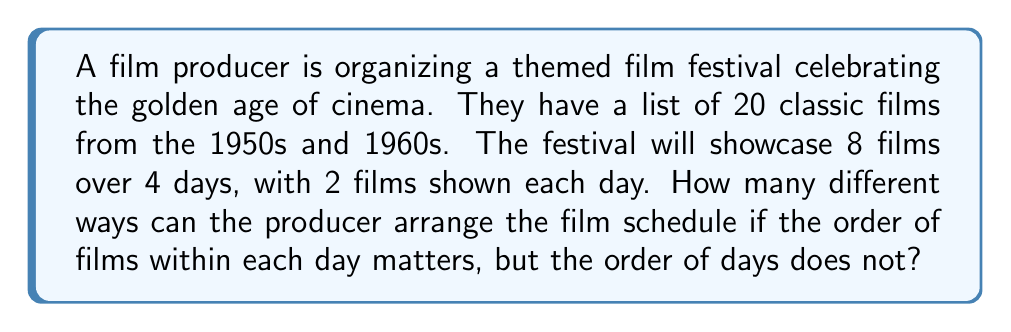Solve this math problem. Let's break this down step-by-step:

1) First, we need to select 8 films out of 20. This is a combination problem:

   $$\binom{20}{8} = \frac{20!}{8!(20-8)!} = \frac{20!}{8!12!} = 125,970$$

2) Now, we need to arrange these 8 films into 4 groups of 2. This is a partition problem.

3) The number of ways to partition 8 distinct objects into 4 groups of 2 is:

   $$\frac{8!}{(2!)^4} = 2,520$$

4) For each partition, the order within each pair matters. There are 2! = 2 ways to arrange each pair.

5) Since there are 4 pairs, the total number of arrangements for each partition is:

   $$(2!)^4 = 16$$

6) However, the order of the days doesn't matter. This means we've overcounted by a factor of 4! (the number of ways to arrange 4 days).

7) Putting it all together:

   $$\text{Total arrangements} = \binom{20}{8} \times \frac{8!}{(2!)^4} \times (2!)^4 \times \frac{1}{4!}$$

8) Simplifying:

   $$125,970 \times 2,520 \times 16 \times \frac{1}{24} = 13,366,752,000$$
Answer: 13,366,752,000 